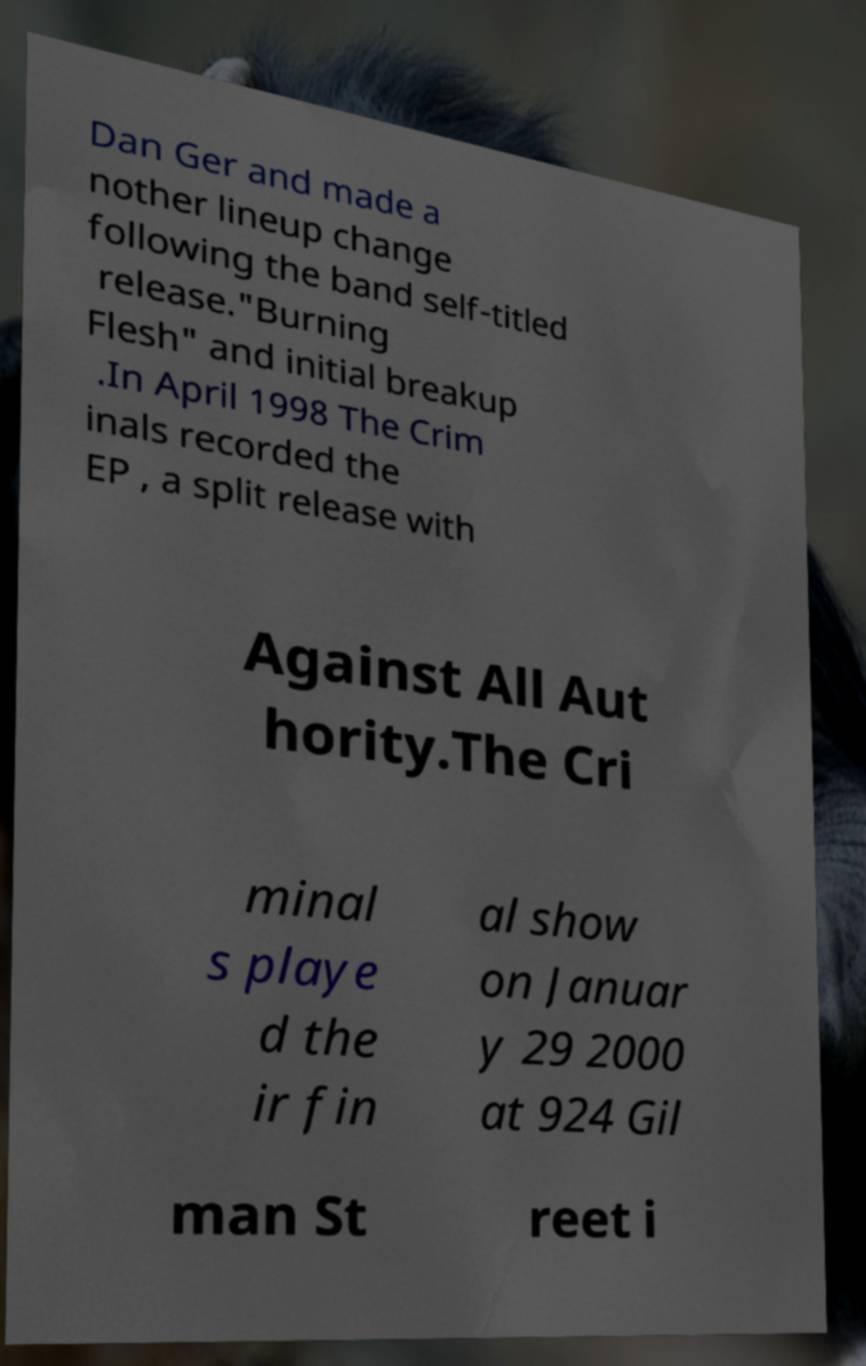Please read and relay the text visible in this image. What does it say? Dan Ger and made a nother lineup change following the band self-titled release."Burning Flesh" and initial breakup .In April 1998 The Crim inals recorded the EP , a split release with Against All Aut hority.The Cri minal s playe d the ir fin al show on Januar y 29 2000 at 924 Gil man St reet i 